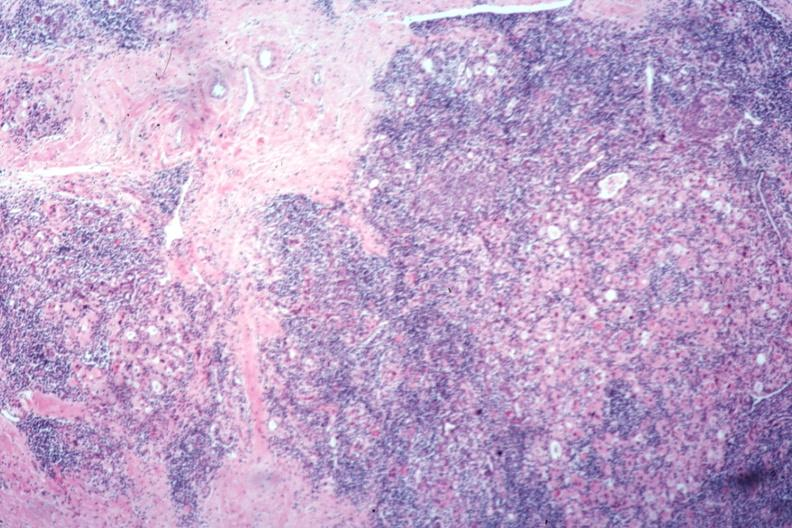does carcinoma show typical severe hashimotos no thyroid tissue recognizable?
Answer the question using a single word or phrase. No 